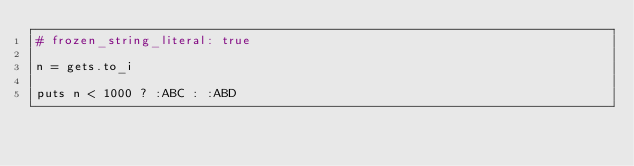Convert code to text. <code><loc_0><loc_0><loc_500><loc_500><_Ruby_># frozen_string_literal: true

n = gets.to_i

puts n < 1000 ? :ABC : :ABD</code> 